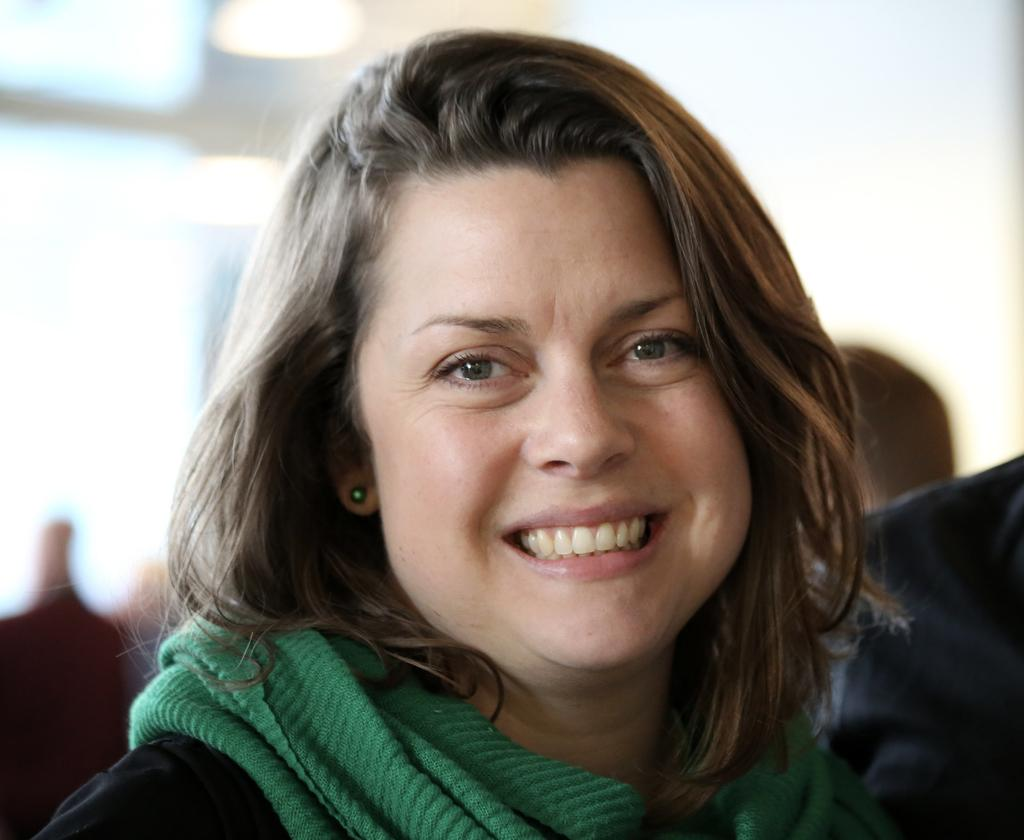Who or what is present in the image? There are people in the image. What can be seen in the background of the image? There are lights and a wall in the background of the image. How many cakes are being expertly burst by the people in the image? There are no cakes or bursting activities present in the image. 